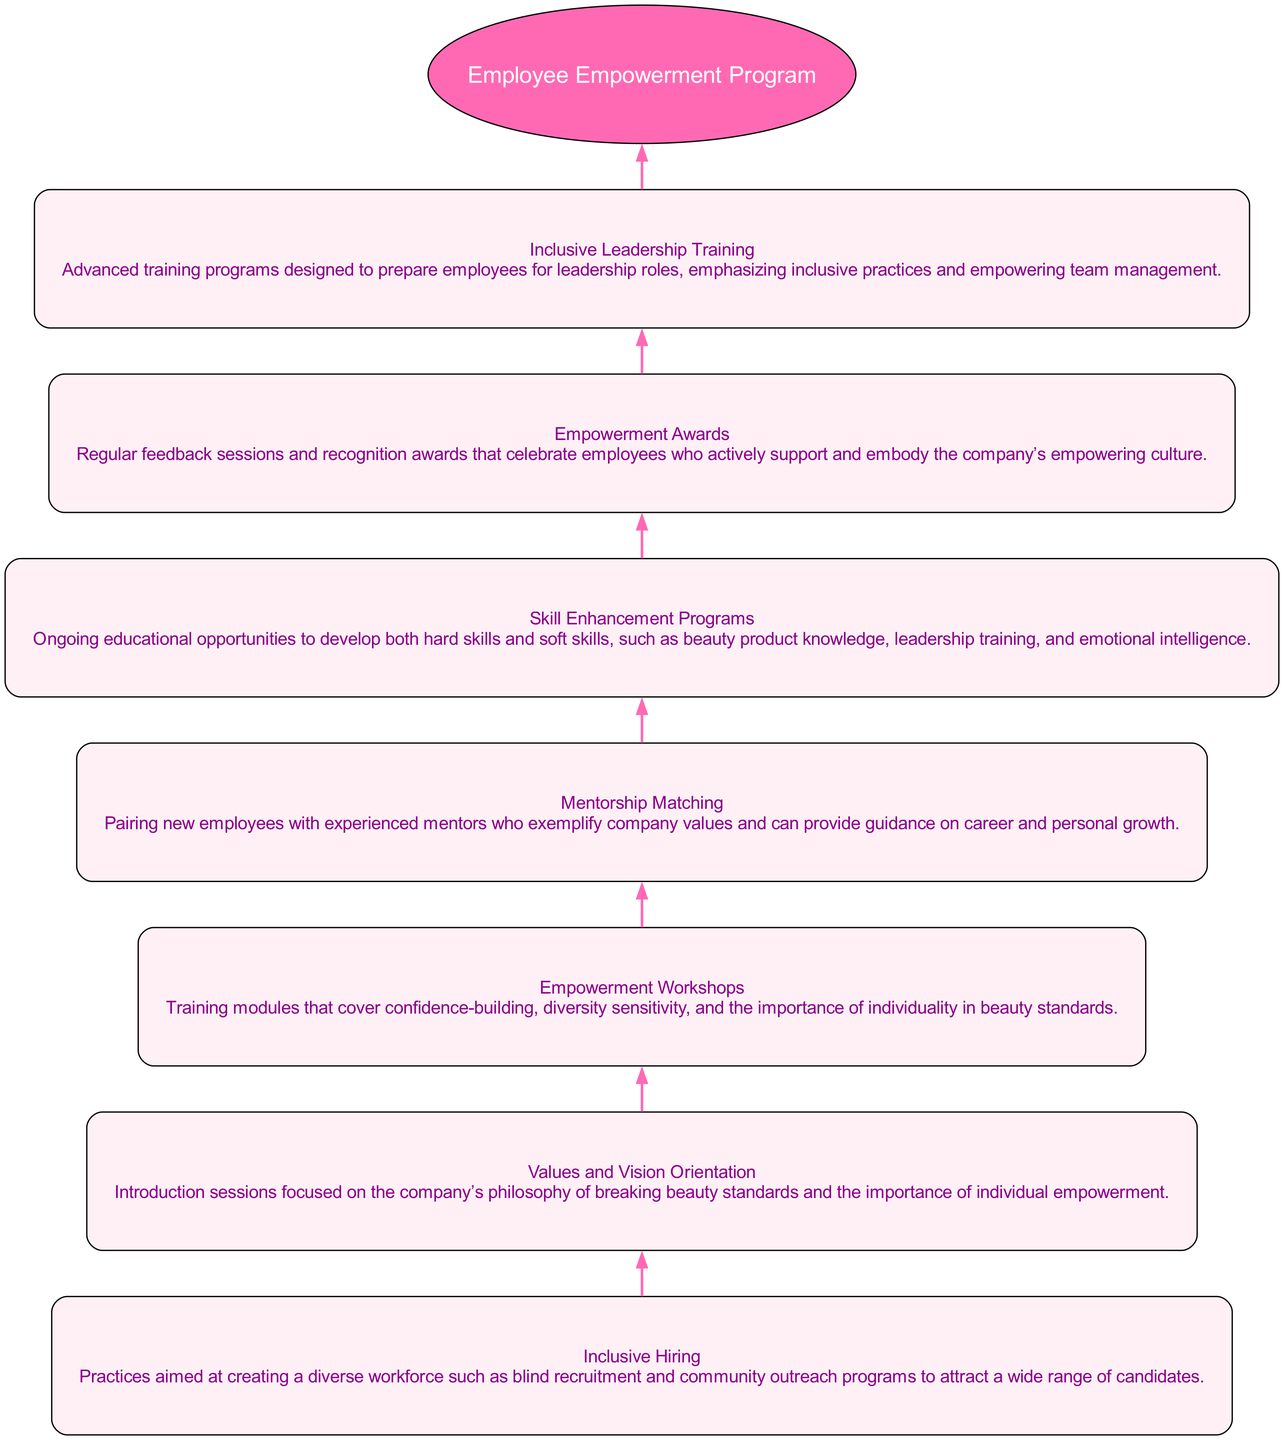What is the title of the recruitment stage? The title can be found directly under the “Recruitment” node in the diagram. The text specifies that the title is "Inclusive Hiring."
Answer: Inclusive Hiring How many main stages are there in the Employee Empowerment Program? Counting the nodes displayed from the diagram, the stages are Recruitment, Onboarding, Training, Mentorship, Continuous Development, Feedback and Recognition, and Leadership Development, totaling seven distinct stages.
Answer: 7 What connects "Continuous Development" and "Feedback and Recognition"? In the flow from bottom to top, "Continuous Development" directly links to "Feedback and Recognition" through a directed edge, establishing a progression from development to recognition.
Answer: An edge What is the purpose of the "Empowerment Awards"? The description of the "Feedback and Recognition" stage indicates that the purpose is to celebrate employees supporting the company's empowering culture, emphasizing recognition and feedback.
Answer: Celebrate employees Which stage discusses pairing new employees with experienced mentors? The stage with this information is "Mentorship," as it specifically describes the process of matching new employees with mentors who embody company values.
Answer: Mentorship What is emphasized in the "Inclusive Leadership Training"? The "Leadership Development" stage specifically mentions that this training emphasizes inclusive practices and empowering team management, indicating its core focus.
Answer: Inclusive practices Which stage follows "Onboarding" in the flow? According to the flow of the diagram, "Training" directly follows "Onboarding," indicating the next step in the employee empowerment process.
Answer: Training What type of training is focused on confidence-building? The “Empowerment Workshops” in the "Training" stage clearly describes that it covers confidence-building among other topics related to beauty standards and sensitivity.
Answer: Empowerment Workshops How does the diagram visually represent the flow of the employee empowerment program? The diagram employs a bottom-to-top flow, where each stage leads to the next in ascending order, demonstrating the process from recruitment to leadership development.
Answer: Bottom-to-top flow 